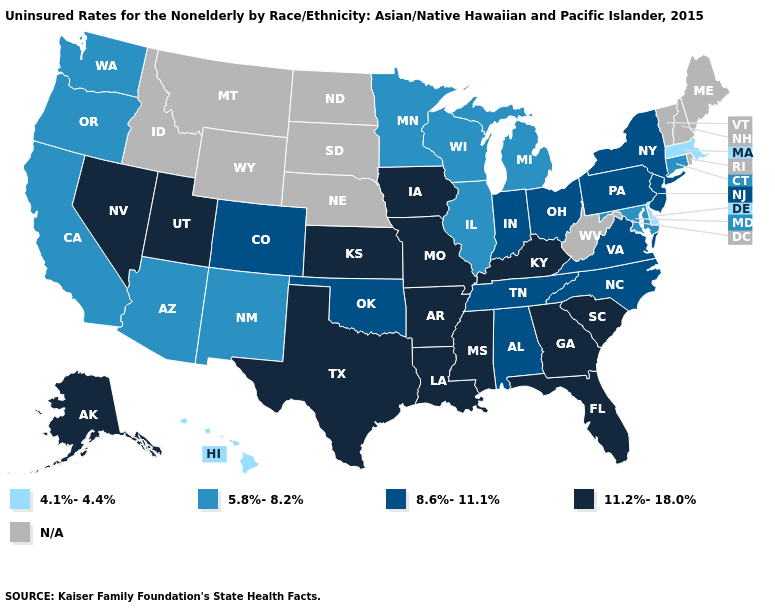What is the value of Maryland?
Concise answer only. 5.8%-8.2%. Name the states that have a value in the range 8.6%-11.1%?
Quick response, please. Alabama, Colorado, Indiana, New Jersey, New York, North Carolina, Ohio, Oklahoma, Pennsylvania, Tennessee, Virginia. What is the value of North Carolina?
Be succinct. 8.6%-11.1%. What is the value of Montana?
Write a very short answer. N/A. Name the states that have a value in the range 8.6%-11.1%?
Give a very brief answer. Alabama, Colorado, Indiana, New Jersey, New York, North Carolina, Ohio, Oklahoma, Pennsylvania, Tennessee, Virginia. What is the value of Mississippi?
Give a very brief answer. 11.2%-18.0%. Among the states that border West Virginia , which have the lowest value?
Keep it brief. Maryland. What is the value of Michigan?
Be succinct. 5.8%-8.2%. What is the highest value in states that border California?
Quick response, please. 11.2%-18.0%. Which states have the lowest value in the USA?
Answer briefly. Delaware, Hawaii, Massachusetts. Name the states that have a value in the range 5.8%-8.2%?
Quick response, please. Arizona, California, Connecticut, Illinois, Maryland, Michigan, Minnesota, New Mexico, Oregon, Washington, Wisconsin. Does Virginia have the highest value in the USA?
Short answer required. No. What is the lowest value in states that border New Hampshire?
Write a very short answer. 4.1%-4.4%. Does the first symbol in the legend represent the smallest category?
Concise answer only. Yes. What is the highest value in the USA?
Answer briefly. 11.2%-18.0%. 